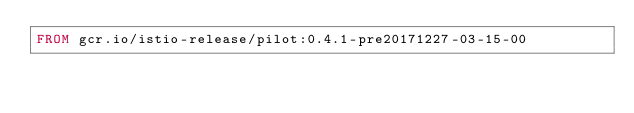<code> <loc_0><loc_0><loc_500><loc_500><_Dockerfile_>FROM gcr.io/istio-release/pilot:0.4.1-pre20171227-03-15-00
</code> 